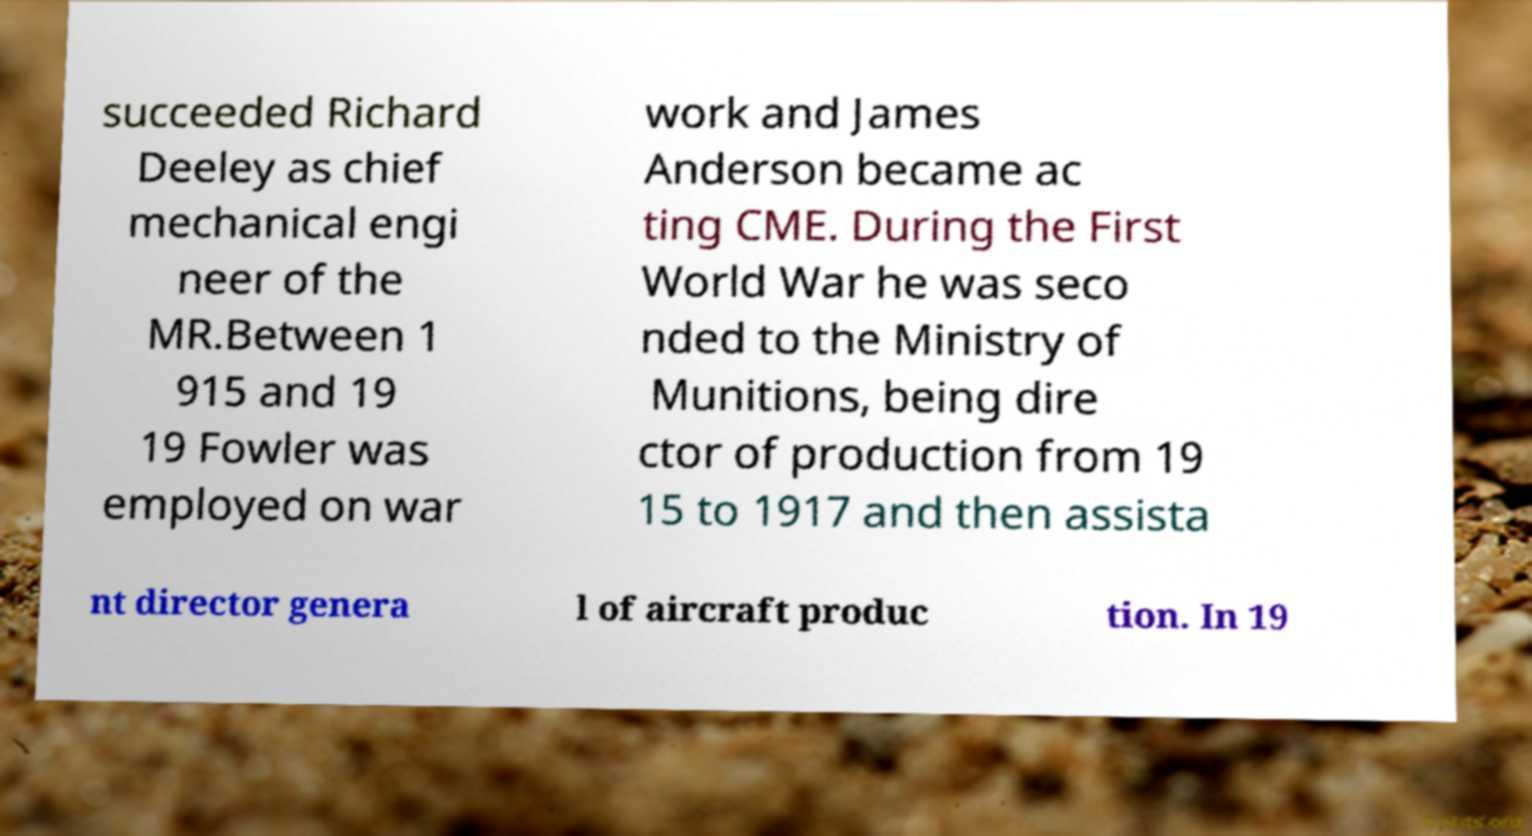Could you extract and type out the text from this image? succeeded Richard Deeley as chief mechanical engi neer of the MR.Between 1 915 and 19 19 Fowler was employed on war work and James Anderson became ac ting CME. During the First World War he was seco nded to the Ministry of Munitions, being dire ctor of production from 19 15 to 1917 and then assista nt director genera l of aircraft produc tion. In 19 